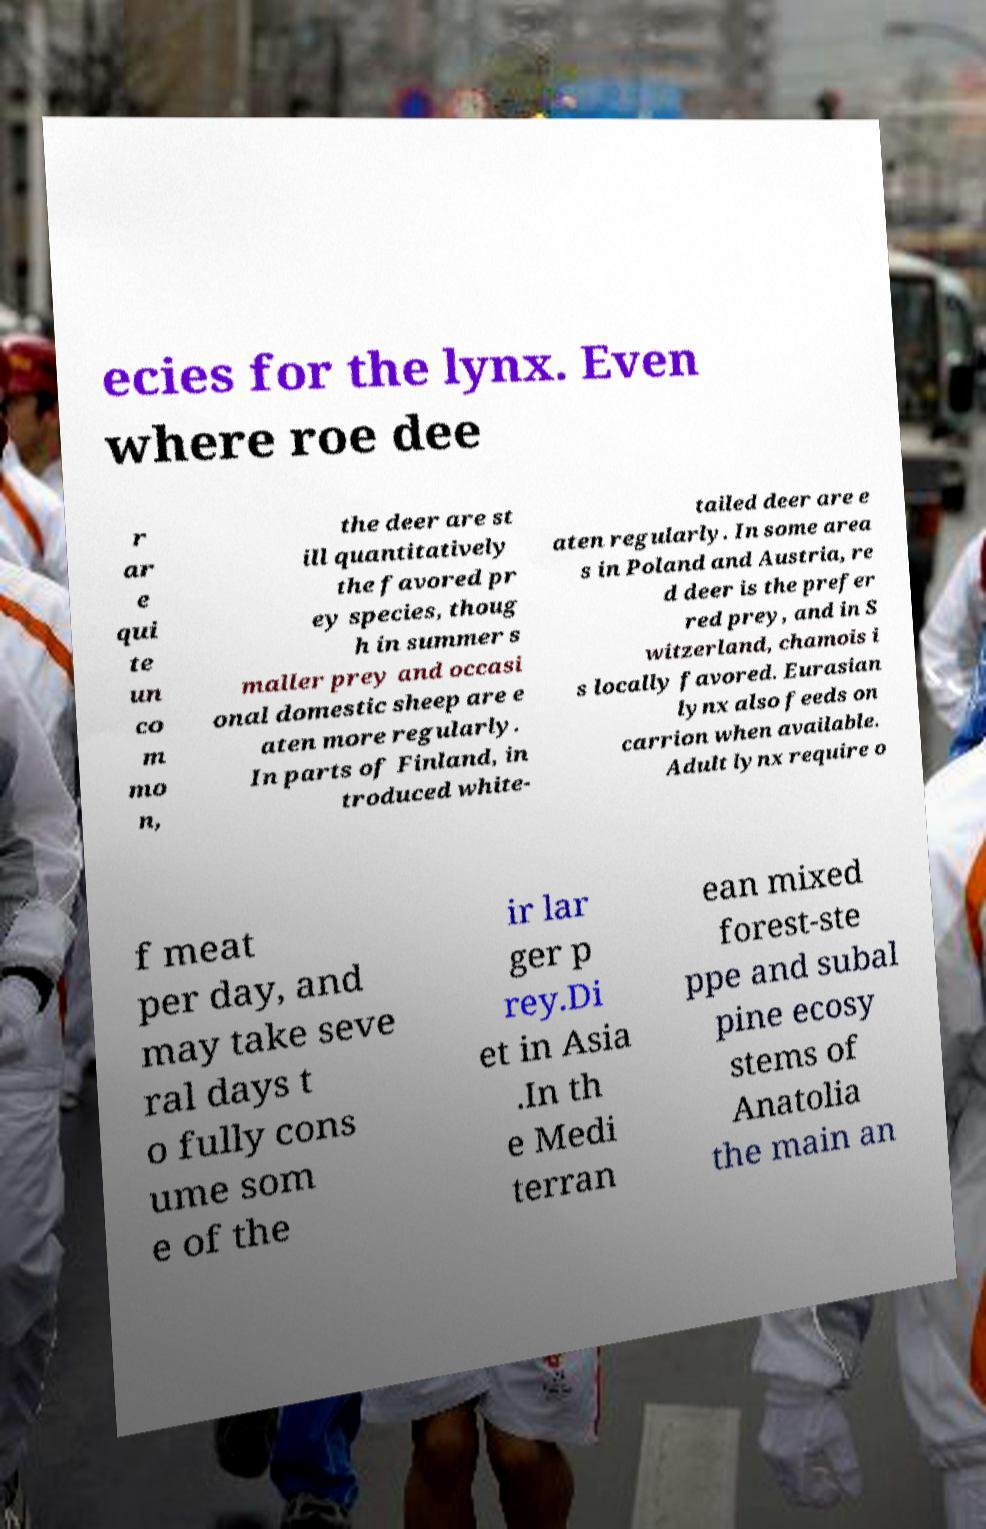What messages or text are displayed in this image? I need them in a readable, typed format. ecies for the lynx. Even where roe dee r ar e qui te un co m mo n, the deer are st ill quantitatively the favored pr ey species, thoug h in summer s maller prey and occasi onal domestic sheep are e aten more regularly. In parts of Finland, in troduced white- tailed deer are e aten regularly. In some area s in Poland and Austria, re d deer is the prefer red prey, and in S witzerland, chamois i s locally favored. Eurasian lynx also feeds on carrion when available. Adult lynx require o f meat per day, and may take seve ral days t o fully cons ume som e of the ir lar ger p rey.Di et in Asia .In th e Medi terran ean mixed forest-ste ppe and subal pine ecosy stems of Anatolia the main an 